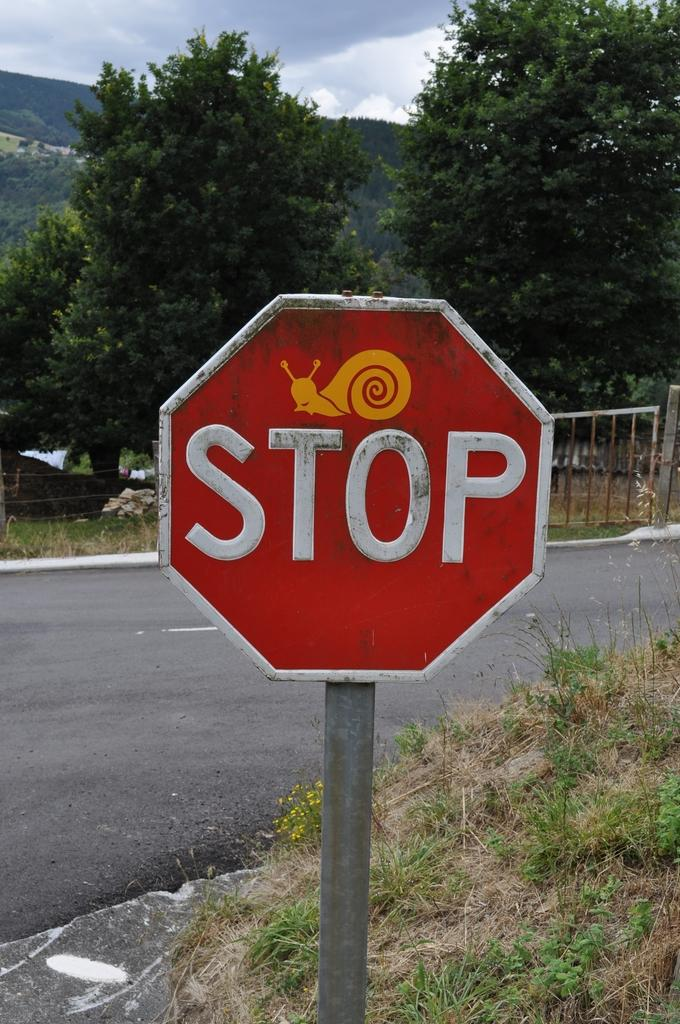<image>
Summarize the visual content of the image. A stop sign is posed at an intersection with a yellow snail sticker above the word STOP. 